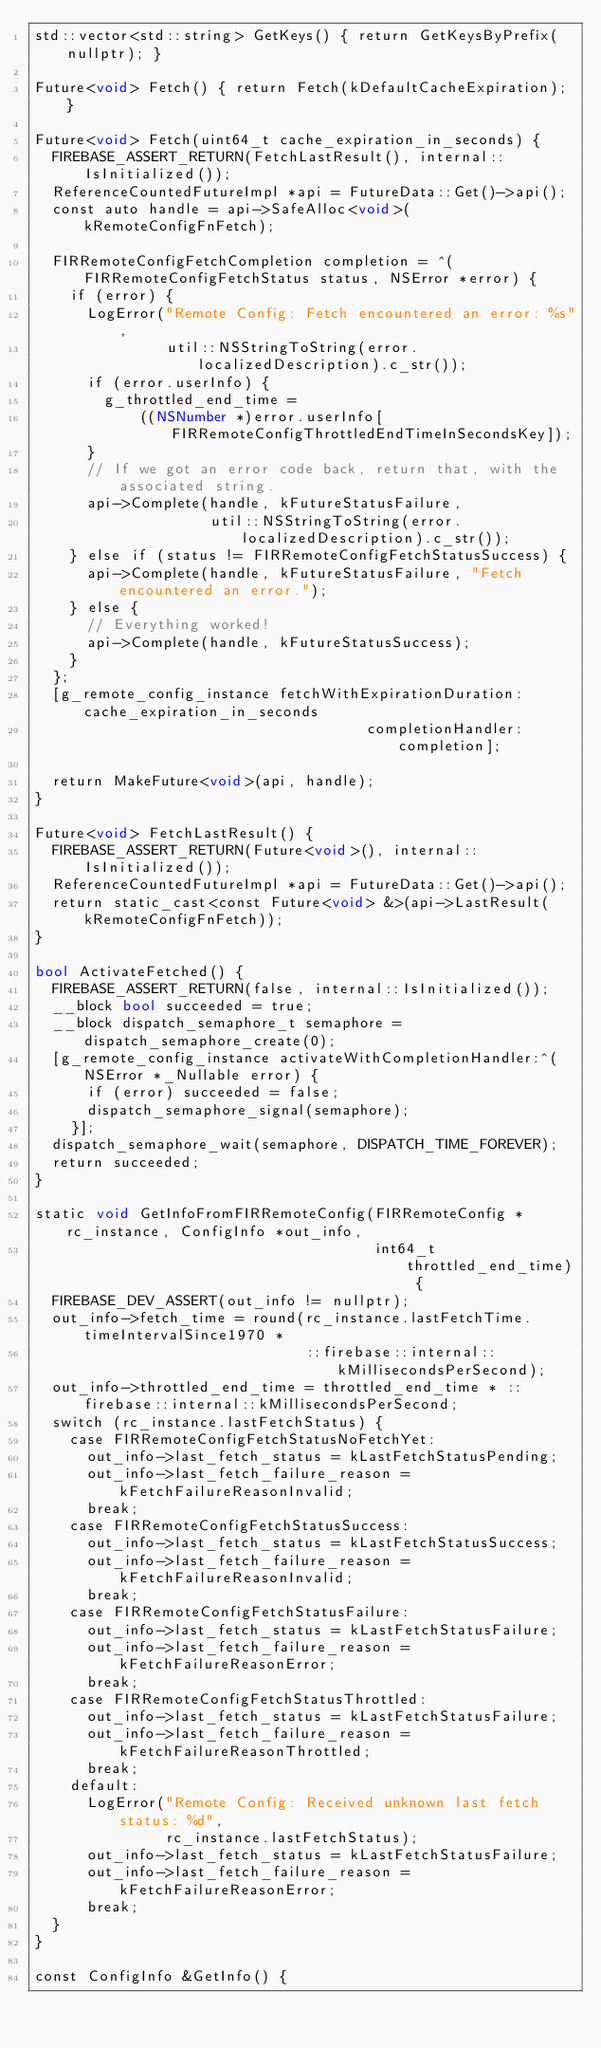<code> <loc_0><loc_0><loc_500><loc_500><_ObjectiveC_>std::vector<std::string> GetKeys() { return GetKeysByPrefix(nullptr); }

Future<void> Fetch() { return Fetch(kDefaultCacheExpiration); }

Future<void> Fetch(uint64_t cache_expiration_in_seconds) {
  FIREBASE_ASSERT_RETURN(FetchLastResult(), internal::IsInitialized());
  ReferenceCountedFutureImpl *api = FutureData::Get()->api();
  const auto handle = api->SafeAlloc<void>(kRemoteConfigFnFetch);

  FIRRemoteConfigFetchCompletion completion = ^(FIRRemoteConfigFetchStatus status, NSError *error) {
    if (error) {
      LogError("Remote Config: Fetch encountered an error: %s",
               util::NSStringToString(error.localizedDescription).c_str());
      if (error.userInfo) {
        g_throttled_end_time =
            ((NSNumber *)error.userInfo[FIRRemoteConfigThrottledEndTimeInSecondsKey]);
      }
      // If we got an error code back, return that, with the associated string.
      api->Complete(handle, kFutureStatusFailure,
                    util::NSStringToString(error.localizedDescription).c_str());
    } else if (status != FIRRemoteConfigFetchStatusSuccess) {
      api->Complete(handle, kFutureStatusFailure, "Fetch encountered an error.");
    } else {
      // Everything worked!
      api->Complete(handle, kFutureStatusSuccess);
    }
  };
  [g_remote_config_instance fetchWithExpirationDuration:cache_expiration_in_seconds
                                      completionHandler:completion];

  return MakeFuture<void>(api, handle);
}

Future<void> FetchLastResult() {
  FIREBASE_ASSERT_RETURN(Future<void>(), internal::IsInitialized());
  ReferenceCountedFutureImpl *api = FutureData::Get()->api();
  return static_cast<const Future<void> &>(api->LastResult(kRemoteConfigFnFetch));
}

bool ActivateFetched() {
  FIREBASE_ASSERT_RETURN(false, internal::IsInitialized());
  __block bool succeeded = true;
  __block dispatch_semaphore_t semaphore = dispatch_semaphore_create(0);
  [g_remote_config_instance activateWithCompletionHandler:^(NSError *_Nullable error) {
      if (error) succeeded = false;
      dispatch_semaphore_signal(semaphore);
    }];
  dispatch_semaphore_wait(semaphore, DISPATCH_TIME_FOREVER);
  return succeeded;
}

static void GetInfoFromFIRRemoteConfig(FIRRemoteConfig *rc_instance, ConfigInfo *out_info,
                                       int64_t throttled_end_time) {
  FIREBASE_DEV_ASSERT(out_info != nullptr);
  out_info->fetch_time = round(rc_instance.lastFetchTime.timeIntervalSince1970 *
                               ::firebase::internal::kMillisecondsPerSecond);
  out_info->throttled_end_time = throttled_end_time * ::firebase::internal::kMillisecondsPerSecond;
  switch (rc_instance.lastFetchStatus) {
    case FIRRemoteConfigFetchStatusNoFetchYet:
      out_info->last_fetch_status = kLastFetchStatusPending;
      out_info->last_fetch_failure_reason = kFetchFailureReasonInvalid;
      break;
    case FIRRemoteConfigFetchStatusSuccess:
      out_info->last_fetch_status = kLastFetchStatusSuccess;
      out_info->last_fetch_failure_reason = kFetchFailureReasonInvalid;
      break;
    case FIRRemoteConfigFetchStatusFailure:
      out_info->last_fetch_status = kLastFetchStatusFailure;
      out_info->last_fetch_failure_reason = kFetchFailureReasonError;
      break;
    case FIRRemoteConfigFetchStatusThrottled:
      out_info->last_fetch_status = kLastFetchStatusFailure;
      out_info->last_fetch_failure_reason = kFetchFailureReasonThrottled;
      break;
    default:
      LogError("Remote Config: Received unknown last fetch status: %d",
               rc_instance.lastFetchStatus);
      out_info->last_fetch_status = kLastFetchStatusFailure;
      out_info->last_fetch_failure_reason = kFetchFailureReasonError;
      break;
  }
}

const ConfigInfo &GetInfo() {</code> 